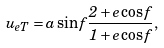Convert formula to latex. <formula><loc_0><loc_0><loc_500><loc_500>u _ { e T } = a \sin f \frac { 2 + e \cos f } { 1 + e \cos f } ,</formula> 